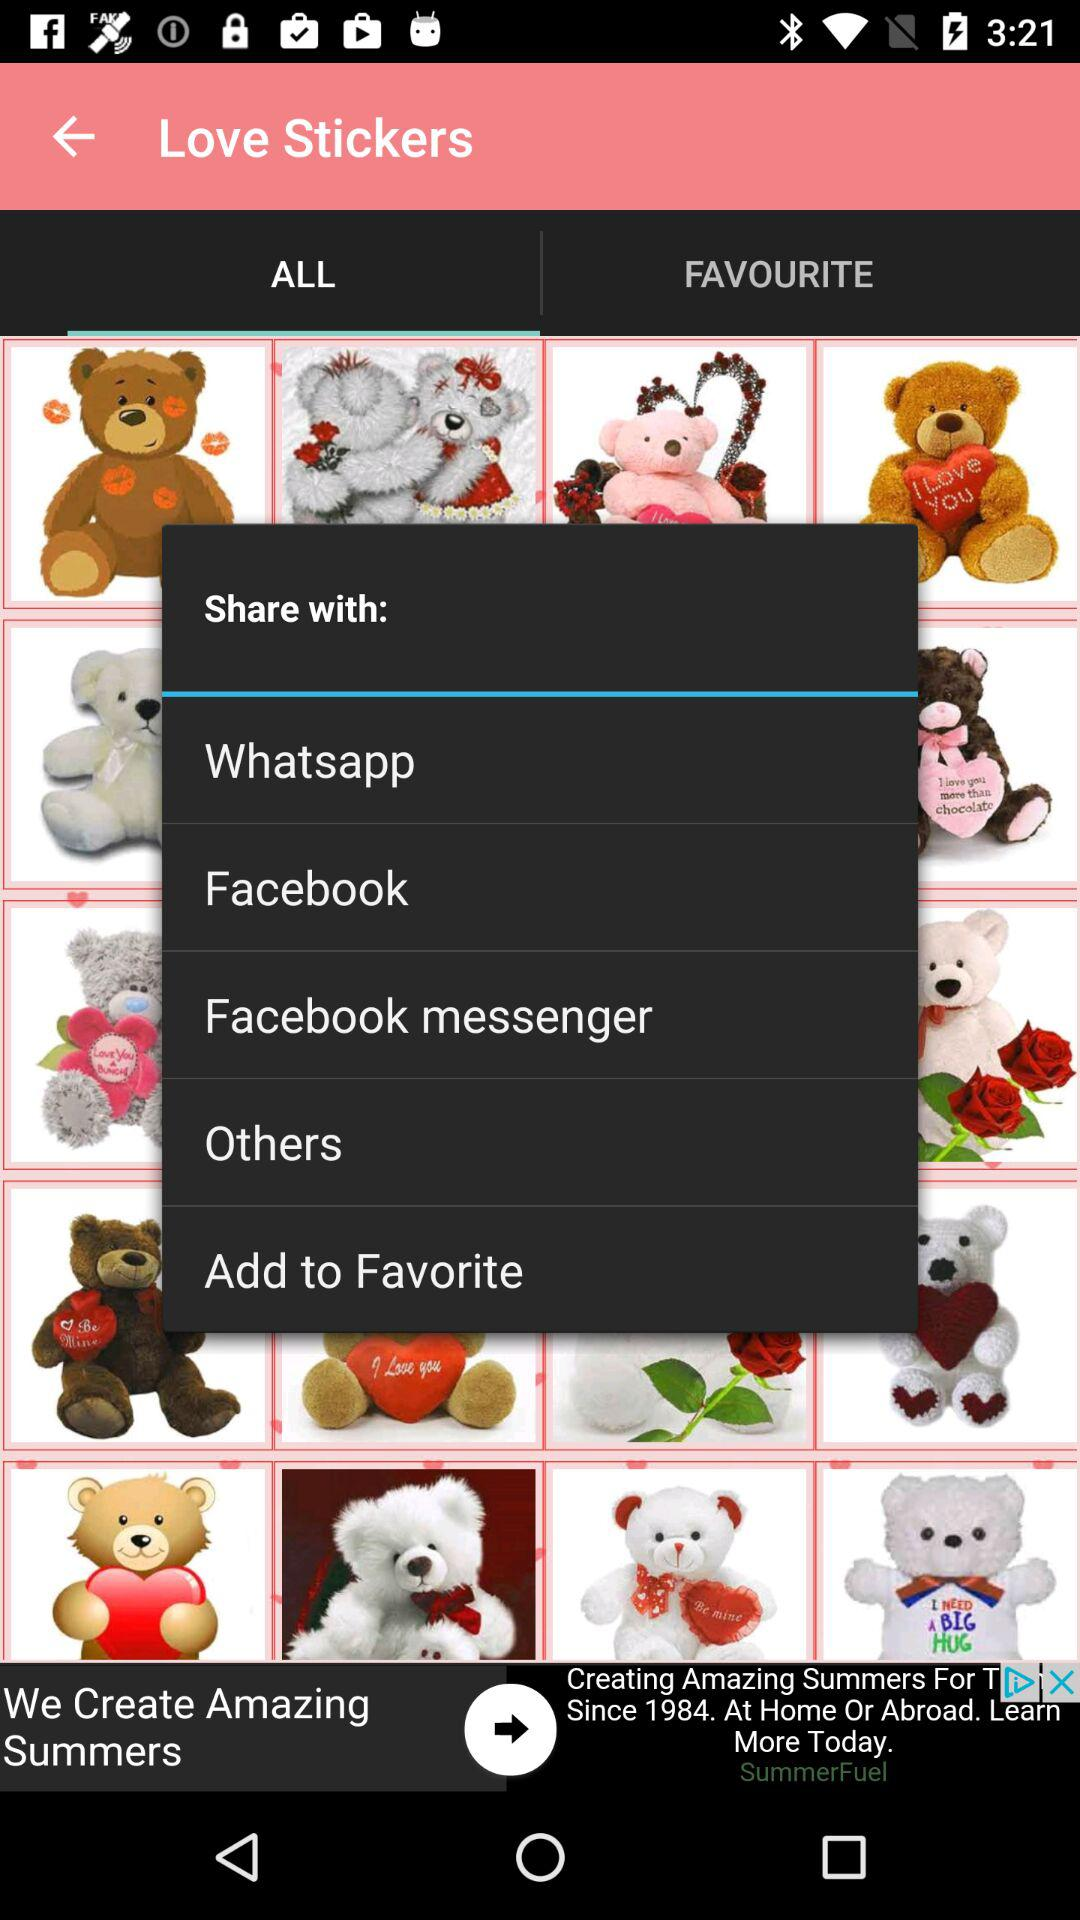Which tab is selected? The selected tab is "ALL". 